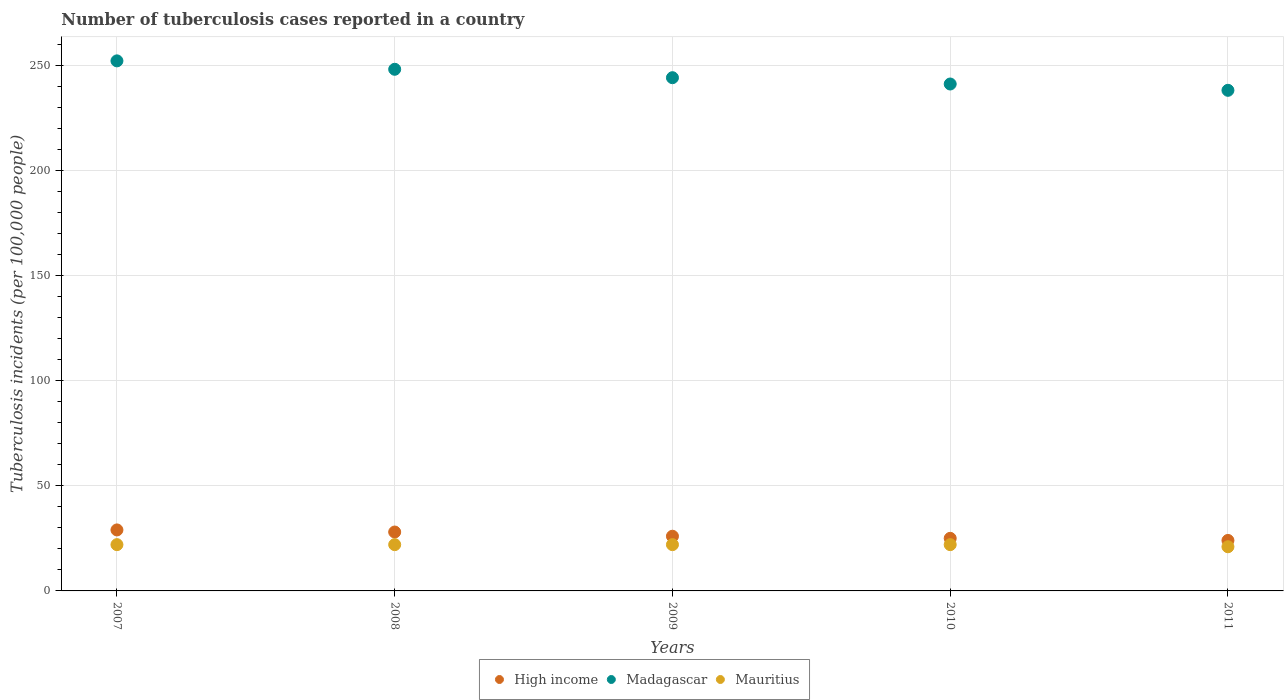What is the number of tuberculosis cases reported in in High income in 2010?
Your answer should be compact. 25. Across all years, what is the maximum number of tuberculosis cases reported in in Madagascar?
Keep it short and to the point. 252. Across all years, what is the minimum number of tuberculosis cases reported in in Madagascar?
Offer a very short reply. 238. What is the total number of tuberculosis cases reported in in Madagascar in the graph?
Keep it short and to the point. 1223. What is the difference between the number of tuberculosis cases reported in in Mauritius in 2009 and that in 2011?
Provide a short and direct response. 1. What is the difference between the number of tuberculosis cases reported in in Madagascar in 2011 and the number of tuberculosis cases reported in in High income in 2010?
Offer a very short reply. 213. What is the average number of tuberculosis cases reported in in Madagascar per year?
Your response must be concise. 244.6. In the year 2011, what is the difference between the number of tuberculosis cases reported in in High income and number of tuberculosis cases reported in in Madagascar?
Give a very brief answer. -214. What is the ratio of the number of tuberculosis cases reported in in Mauritius in 2010 to that in 2011?
Give a very brief answer. 1.05. Is the number of tuberculosis cases reported in in Madagascar in 2008 less than that in 2011?
Offer a terse response. No. What is the difference between the highest and the second highest number of tuberculosis cases reported in in High income?
Provide a short and direct response. 1. What is the difference between the highest and the lowest number of tuberculosis cases reported in in Madagascar?
Give a very brief answer. 14. In how many years, is the number of tuberculosis cases reported in in High income greater than the average number of tuberculosis cases reported in in High income taken over all years?
Your answer should be very brief. 2. Is the sum of the number of tuberculosis cases reported in in High income in 2009 and 2011 greater than the maximum number of tuberculosis cases reported in in Mauritius across all years?
Your answer should be very brief. Yes. Is it the case that in every year, the sum of the number of tuberculosis cases reported in in Mauritius and number of tuberculosis cases reported in in High income  is greater than the number of tuberculosis cases reported in in Madagascar?
Your answer should be compact. No. Does the number of tuberculosis cases reported in in High income monotonically increase over the years?
Give a very brief answer. No. What is the difference between two consecutive major ticks on the Y-axis?
Offer a terse response. 50. Are the values on the major ticks of Y-axis written in scientific E-notation?
Offer a very short reply. No. How many legend labels are there?
Make the answer very short. 3. What is the title of the graph?
Provide a succinct answer. Number of tuberculosis cases reported in a country. What is the label or title of the Y-axis?
Ensure brevity in your answer.  Tuberculosis incidents (per 100,0 people). What is the Tuberculosis incidents (per 100,000 people) of High income in 2007?
Your answer should be very brief. 29. What is the Tuberculosis incidents (per 100,000 people) of Madagascar in 2007?
Make the answer very short. 252. What is the Tuberculosis incidents (per 100,000 people) in High income in 2008?
Keep it short and to the point. 28. What is the Tuberculosis incidents (per 100,000 people) in Madagascar in 2008?
Offer a terse response. 248. What is the Tuberculosis incidents (per 100,000 people) in High income in 2009?
Provide a succinct answer. 26. What is the Tuberculosis incidents (per 100,000 people) in Madagascar in 2009?
Offer a terse response. 244. What is the Tuberculosis incidents (per 100,000 people) of High income in 2010?
Give a very brief answer. 25. What is the Tuberculosis incidents (per 100,000 people) in Madagascar in 2010?
Your answer should be very brief. 241. What is the Tuberculosis incidents (per 100,000 people) in Mauritius in 2010?
Your answer should be very brief. 22. What is the Tuberculosis incidents (per 100,000 people) of High income in 2011?
Your answer should be very brief. 24. What is the Tuberculosis incidents (per 100,000 people) in Madagascar in 2011?
Ensure brevity in your answer.  238. Across all years, what is the maximum Tuberculosis incidents (per 100,000 people) in High income?
Offer a very short reply. 29. Across all years, what is the maximum Tuberculosis incidents (per 100,000 people) in Madagascar?
Provide a succinct answer. 252. Across all years, what is the minimum Tuberculosis incidents (per 100,000 people) of Madagascar?
Provide a succinct answer. 238. Across all years, what is the minimum Tuberculosis incidents (per 100,000 people) of Mauritius?
Provide a succinct answer. 21. What is the total Tuberculosis incidents (per 100,000 people) of High income in the graph?
Provide a short and direct response. 132. What is the total Tuberculosis incidents (per 100,000 people) of Madagascar in the graph?
Provide a short and direct response. 1223. What is the total Tuberculosis incidents (per 100,000 people) of Mauritius in the graph?
Offer a terse response. 109. What is the difference between the Tuberculosis incidents (per 100,000 people) in High income in 2007 and that in 2008?
Your answer should be compact. 1. What is the difference between the Tuberculosis incidents (per 100,000 people) of Mauritius in 2007 and that in 2008?
Provide a succinct answer. 0. What is the difference between the Tuberculosis incidents (per 100,000 people) in High income in 2007 and that in 2009?
Ensure brevity in your answer.  3. What is the difference between the Tuberculosis incidents (per 100,000 people) in Mauritius in 2007 and that in 2010?
Make the answer very short. 0. What is the difference between the Tuberculosis incidents (per 100,000 people) in High income in 2007 and that in 2011?
Provide a succinct answer. 5. What is the difference between the Tuberculosis incidents (per 100,000 people) of Mauritius in 2007 and that in 2011?
Provide a succinct answer. 1. What is the difference between the Tuberculosis incidents (per 100,000 people) in Madagascar in 2008 and that in 2009?
Provide a succinct answer. 4. What is the difference between the Tuberculosis incidents (per 100,000 people) of Mauritius in 2008 and that in 2009?
Offer a very short reply. 0. What is the difference between the Tuberculosis incidents (per 100,000 people) in Madagascar in 2008 and that in 2011?
Offer a very short reply. 10. What is the difference between the Tuberculosis incidents (per 100,000 people) of Mauritius in 2008 and that in 2011?
Your answer should be very brief. 1. What is the difference between the Tuberculosis incidents (per 100,000 people) of High income in 2009 and that in 2010?
Your response must be concise. 1. What is the difference between the Tuberculosis incidents (per 100,000 people) in Madagascar in 2009 and that in 2010?
Provide a succinct answer. 3. What is the difference between the Tuberculosis incidents (per 100,000 people) of High income in 2010 and that in 2011?
Your answer should be compact. 1. What is the difference between the Tuberculosis incidents (per 100,000 people) in Mauritius in 2010 and that in 2011?
Give a very brief answer. 1. What is the difference between the Tuberculosis incidents (per 100,000 people) in High income in 2007 and the Tuberculosis incidents (per 100,000 people) in Madagascar in 2008?
Ensure brevity in your answer.  -219. What is the difference between the Tuberculosis incidents (per 100,000 people) in Madagascar in 2007 and the Tuberculosis incidents (per 100,000 people) in Mauritius in 2008?
Make the answer very short. 230. What is the difference between the Tuberculosis incidents (per 100,000 people) in High income in 2007 and the Tuberculosis incidents (per 100,000 people) in Madagascar in 2009?
Offer a very short reply. -215. What is the difference between the Tuberculosis incidents (per 100,000 people) in High income in 2007 and the Tuberculosis incidents (per 100,000 people) in Mauritius in 2009?
Give a very brief answer. 7. What is the difference between the Tuberculosis incidents (per 100,000 people) in Madagascar in 2007 and the Tuberculosis incidents (per 100,000 people) in Mauritius in 2009?
Ensure brevity in your answer.  230. What is the difference between the Tuberculosis incidents (per 100,000 people) in High income in 2007 and the Tuberculosis incidents (per 100,000 people) in Madagascar in 2010?
Give a very brief answer. -212. What is the difference between the Tuberculosis incidents (per 100,000 people) of High income in 2007 and the Tuberculosis incidents (per 100,000 people) of Mauritius in 2010?
Give a very brief answer. 7. What is the difference between the Tuberculosis incidents (per 100,000 people) in Madagascar in 2007 and the Tuberculosis incidents (per 100,000 people) in Mauritius in 2010?
Ensure brevity in your answer.  230. What is the difference between the Tuberculosis incidents (per 100,000 people) of High income in 2007 and the Tuberculosis incidents (per 100,000 people) of Madagascar in 2011?
Ensure brevity in your answer.  -209. What is the difference between the Tuberculosis incidents (per 100,000 people) of Madagascar in 2007 and the Tuberculosis incidents (per 100,000 people) of Mauritius in 2011?
Offer a terse response. 231. What is the difference between the Tuberculosis incidents (per 100,000 people) in High income in 2008 and the Tuberculosis incidents (per 100,000 people) in Madagascar in 2009?
Your answer should be compact. -216. What is the difference between the Tuberculosis incidents (per 100,000 people) in Madagascar in 2008 and the Tuberculosis incidents (per 100,000 people) in Mauritius in 2009?
Your answer should be compact. 226. What is the difference between the Tuberculosis incidents (per 100,000 people) in High income in 2008 and the Tuberculosis incidents (per 100,000 people) in Madagascar in 2010?
Offer a very short reply. -213. What is the difference between the Tuberculosis incidents (per 100,000 people) of Madagascar in 2008 and the Tuberculosis incidents (per 100,000 people) of Mauritius in 2010?
Provide a short and direct response. 226. What is the difference between the Tuberculosis incidents (per 100,000 people) in High income in 2008 and the Tuberculosis incidents (per 100,000 people) in Madagascar in 2011?
Your answer should be compact. -210. What is the difference between the Tuberculosis incidents (per 100,000 people) in High income in 2008 and the Tuberculosis incidents (per 100,000 people) in Mauritius in 2011?
Offer a very short reply. 7. What is the difference between the Tuberculosis incidents (per 100,000 people) in Madagascar in 2008 and the Tuberculosis incidents (per 100,000 people) in Mauritius in 2011?
Ensure brevity in your answer.  227. What is the difference between the Tuberculosis incidents (per 100,000 people) in High income in 2009 and the Tuberculosis incidents (per 100,000 people) in Madagascar in 2010?
Make the answer very short. -215. What is the difference between the Tuberculosis incidents (per 100,000 people) in High income in 2009 and the Tuberculosis incidents (per 100,000 people) in Mauritius in 2010?
Your response must be concise. 4. What is the difference between the Tuberculosis incidents (per 100,000 people) of Madagascar in 2009 and the Tuberculosis incidents (per 100,000 people) of Mauritius in 2010?
Your answer should be very brief. 222. What is the difference between the Tuberculosis incidents (per 100,000 people) in High income in 2009 and the Tuberculosis incidents (per 100,000 people) in Madagascar in 2011?
Make the answer very short. -212. What is the difference between the Tuberculosis incidents (per 100,000 people) of High income in 2009 and the Tuberculosis incidents (per 100,000 people) of Mauritius in 2011?
Ensure brevity in your answer.  5. What is the difference between the Tuberculosis incidents (per 100,000 people) of Madagascar in 2009 and the Tuberculosis incidents (per 100,000 people) of Mauritius in 2011?
Keep it short and to the point. 223. What is the difference between the Tuberculosis incidents (per 100,000 people) in High income in 2010 and the Tuberculosis incidents (per 100,000 people) in Madagascar in 2011?
Offer a very short reply. -213. What is the difference between the Tuberculosis incidents (per 100,000 people) in High income in 2010 and the Tuberculosis incidents (per 100,000 people) in Mauritius in 2011?
Ensure brevity in your answer.  4. What is the difference between the Tuberculosis incidents (per 100,000 people) in Madagascar in 2010 and the Tuberculosis incidents (per 100,000 people) in Mauritius in 2011?
Your answer should be compact. 220. What is the average Tuberculosis incidents (per 100,000 people) in High income per year?
Give a very brief answer. 26.4. What is the average Tuberculosis incidents (per 100,000 people) in Madagascar per year?
Your answer should be compact. 244.6. What is the average Tuberculosis incidents (per 100,000 people) in Mauritius per year?
Offer a terse response. 21.8. In the year 2007, what is the difference between the Tuberculosis incidents (per 100,000 people) of High income and Tuberculosis incidents (per 100,000 people) of Madagascar?
Offer a very short reply. -223. In the year 2007, what is the difference between the Tuberculosis incidents (per 100,000 people) in Madagascar and Tuberculosis incidents (per 100,000 people) in Mauritius?
Provide a short and direct response. 230. In the year 2008, what is the difference between the Tuberculosis incidents (per 100,000 people) of High income and Tuberculosis incidents (per 100,000 people) of Madagascar?
Provide a succinct answer. -220. In the year 2008, what is the difference between the Tuberculosis incidents (per 100,000 people) of High income and Tuberculosis incidents (per 100,000 people) of Mauritius?
Keep it short and to the point. 6. In the year 2008, what is the difference between the Tuberculosis incidents (per 100,000 people) of Madagascar and Tuberculosis incidents (per 100,000 people) of Mauritius?
Give a very brief answer. 226. In the year 2009, what is the difference between the Tuberculosis incidents (per 100,000 people) in High income and Tuberculosis incidents (per 100,000 people) in Madagascar?
Offer a terse response. -218. In the year 2009, what is the difference between the Tuberculosis incidents (per 100,000 people) of High income and Tuberculosis incidents (per 100,000 people) of Mauritius?
Provide a succinct answer. 4. In the year 2009, what is the difference between the Tuberculosis incidents (per 100,000 people) in Madagascar and Tuberculosis incidents (per 100,000 people) in Mauritius?
Keep it short and to the point. 222. In the year 2010, what is the difference between the Tuberculosis incidents (per 100,000 people) in High income and Tuberculosis incidents (per 100,000 people) in Madagascar?
Keep it short and to the point. -216. In the year 2010, what is the difference between the Tuberculosis incidents (per 100,000 people) of High income and Tuberculosis incidents (per 100,000 people) of Mauritius?
Make the answer very short. 3. In the year 2010, what is the difference between the Tuberculosis incidents (per 100,000 people) of Madagascar and Tuberculosis incidents (per 100,000 people) of Mauritius?
Keep it short and to the point. 219. In the year 2011, what is the difference between the Tuberculosis incidents (per 100,000 people) of High income and Tuberculosis incidents (per 100,000 people) of Madagascar?
Your answer should be very brief. -214. In the year 2011, what is the difference between the Tuberculosis incidents (per 100,000 people) of Madagascar and Tuberculosis incidents (per 100,000 people) of Mauritius?
Keep it short and to the point. 217. What is the ratio of the Tuberculosis incidents (per 100,000 people) in High income in 2007 to that in 2008?
Your answer should be very brief. 1.04. What is the ratio of the Tuberculosis incidents (per 100,000 people) in Madagascar in 2007 to that in 2008?
Your answer should be very brief. 1.02. What is the ratio of the Tuberculosis incidents (per 100,000 people) of Mauritius in 2007 to that in 2008?
Your answer should be compact. 1. What is the ratio of the Tuberculosis incidents (per 100,000 people) of High income in 2007 to that in 2009?
Provide a succinct answer. 1.12. What is the ratio of the Tuberculosis incidents (per 100,000 people) in Madagascar in 2007 to that in 2009?
Provide a succinct answer. 1.03. What is the ratio of the Tuberculosis incidents (per 100,000 people) in High income in 2007 to that in 2010?
Offer a terse response. 1.16. What is the ratio of the Tuberculosis incidents (per 100,000 people) in Madagascar in 2007 to that in 2010?
Your response must be concise. 1.05. What is the ratio of the Tuberculosis incidents (per 100,000 people) of Mauritius in 2007 to that in 2010?
Offer a terse response. 1. What is the ratio of the Tuberculosis incidents (per 100,000 people) of High income in 2007 to that in 2011?
Provide a succinct answer. 1.21. What is the ratio of the Tuberculosis incidents (per 100,000 people) in Madagascar in 2007 to that in 2011?
Give a very brief answer. 1.06. What is the ratio of the Tuberculosis incidents (per 100,000 people) of Mauritius in 2007 to that in 2011?
Offer a terse response. 1.05. What is the ratio of the Tuberculosis incidents (per 100,000 people) of High income in 2008 to that in 2009?
Ensure brevity in your answer.  1.08. What is the ratio of the Tuberculosis incidents (per 100,000 people) of Madagascar in 2008 to that in 2009?
Give a very brief answer. 1.02. What is the ratio of the Tuberculosis incidents (per 100,000 people) in High income in 2008 to that in 2010?
Offer a very short reply. 1.12. What is the ratio of the Tuberculosis incidents (per 100,000 people) in Madagascar in 2008 to that in 2010?
Your response must be concise. 1.03. What is the ratio of the Tuberculosis incidents (per 100,000 people) of Mauritius in 2008 to that in 2010?
Give a very brief answer. 1. What is the ratio of the Tuberculosis incidents (per 100,000 people) of High income in 2008 to that in 2011?
Your answer should be very brief. 1.17. What is the ratio of the Tuberculosis incidents (per 100,000 people) in Madagascar in 2008 to that in 2011?
Provide a short and direct response. 1.04. What is the ratio of the Tuberculosis incidents (per 100,000 people) in Mauritius in 2008 to that in 2011?
Ensure brevity in your answer.  1.05. What is the ratio of the Tuberculosis incidents (per 100,000 people) in High income in 2009 to that in 2010?
Your answer should be very brief. 1.04. What is the ratio of the Tuberculosis incidents (per 100,000 people) in Madagascar in 2009 to that in 2010?
Provide a succinct answer. 1.01. What is the ratio of the Tuberculosis incidents (per 100,000 people) of Mauritius in 2009 to that in 2010?
Your answer should be very brief. 1. What is the ratio of the Tuberculosis incidents (per 100,000 people) of Madagascar in 2009 to that in 2011?
Provide a succinct answer. 1.03. What is the ratio of the Tuberculosis incidents (per 100,000 people) in Mauritius in 2009 to that in 2011?
Your answer should be very brief. 1.05. What is the ratio of the Tuberculosis incidents (per 100,000 people) in High income in 2010 to that in 2011?
Provide a succinct answer. 1.04. What is the ratio of the Tuberculosis incidents (per 100,000 people) of Madagascar in 2010 to that in 2011?
Offer a very short reply. 1.01. What is the ratio of the Tuberculosis incidents (per 100,000 people) in Mauritius in 2010 to that in 2011?
Provide a short and direct response. 1.05. What is the difference between the highest and the second highest Tuberculosis incidents (per 100,000 people) in High income?
Make the answer very short. 1. What is the difference between the highest and the second highest Tuberculosis incidents (per 100,000 people) of Madagascar?
Offer a terse response. 4. 